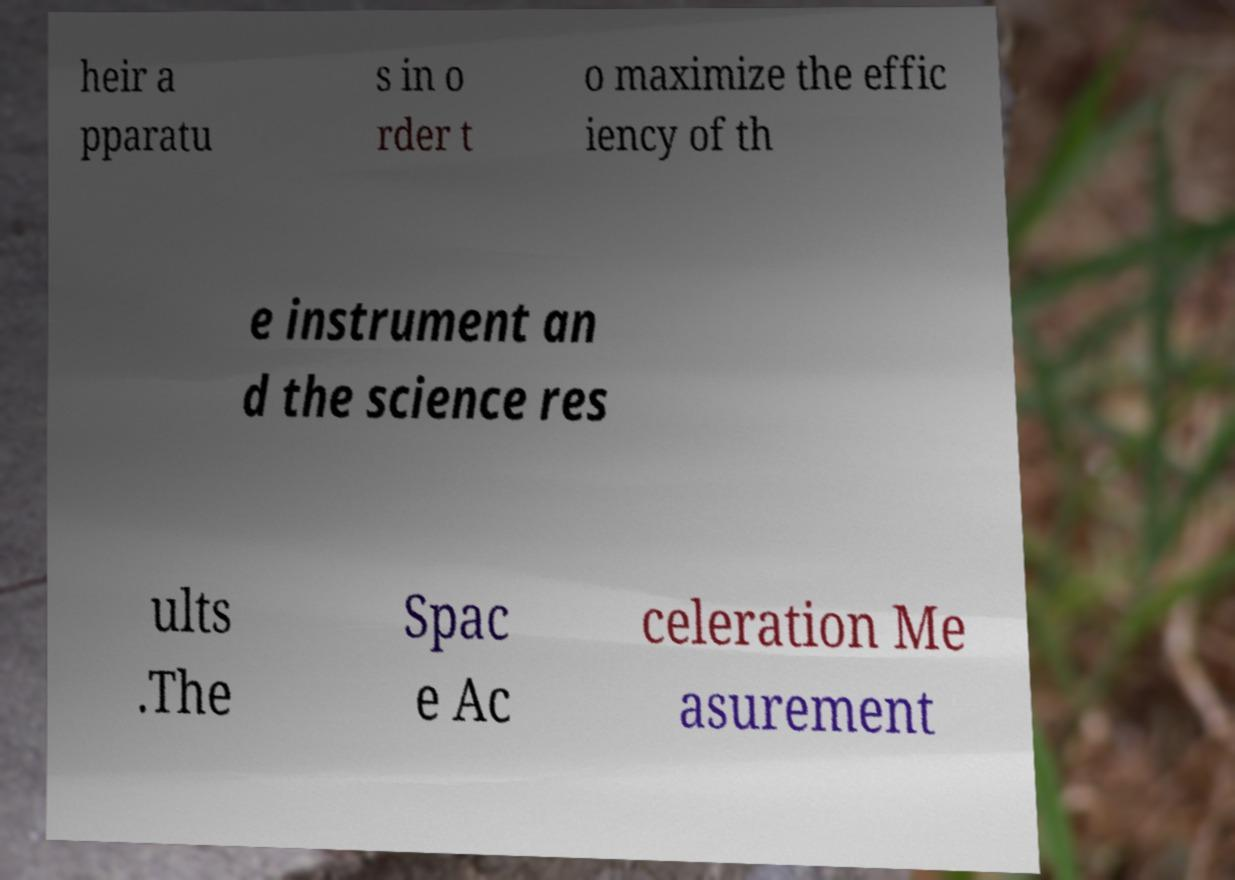What messages or text are displayed in this image? I need them in a readable, typed format. heir a pparatu s in o rder t o maximize the effic iency of th e instrument an d the science res ults .The Spac e Ac celeration Me asurement 